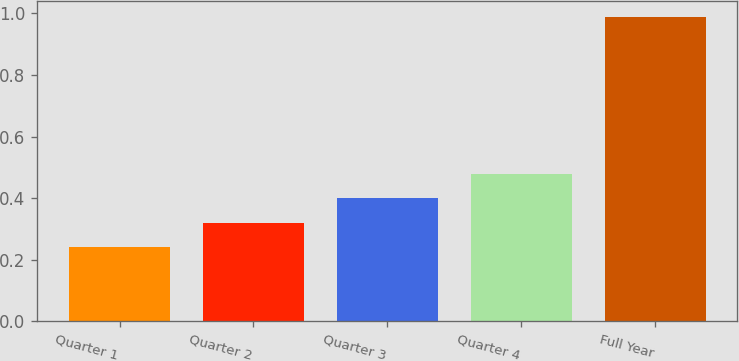Convert chart. <chart><loc_0><loc_0><loc_500><loc_500><bar_chart><fcel>Quarter 1<fcel>Quarter 2<fcel>Quarter 3<fcel>Quarter 4<fcel>Full Year<nl><fcel>0.24<fcel>0.32<fcel>0.4<fcel>0.48<fcel>0.99<nl></chart> 